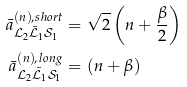<formula> <loc_0><loc_0><loc_500><loc_500>\bar { a } ^ { ( n ) , s h o r t } _ { \mathcal { L } _ { 2 } \bar { \mathcal { L } } _ { 1 } \mathcal { S } _ { 1 } } & = \sqrt { 2 } \left ( n + \frac { \beta } { 2 } \right ) \\ \bar { a } ^ { ( n ) , l o n g } _ { \mathcal { L } _ { 2 } \bar { \mathcal { L } } _ { 1 } \mathcal { S } _ { 1 } } & = ( n + \beta )</formula> 